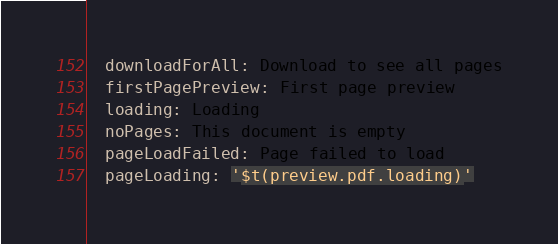Convert code to text. <code><loc_0><loc_0><loc_500><loc_500><_YAML_>  downloadForAll: Download to see all pages
  firstPagePreview: First page preview
  loading: Loading
  noPages: This document is empty
  pageLoadFailed: Page failed to load
  pageLoading: '$t(preview.pdf.loading)'
</code> 